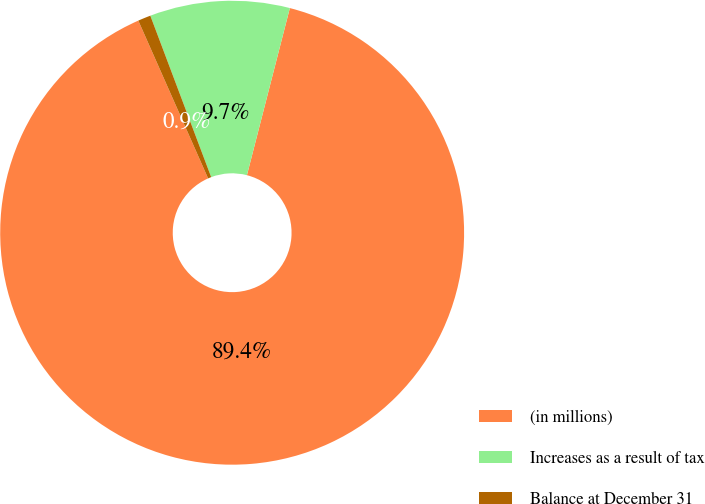Convert chart to OTSL. <chart><loc_0><loc_0><loc_500><loc_500><pie_chart><fcel>(in millions)<fcel>Increases as a result of tax<fcel>Balance at December 31<nl><fcel>89.37%<fcel>9.74%<fcel>0.89%<nl></chart> 